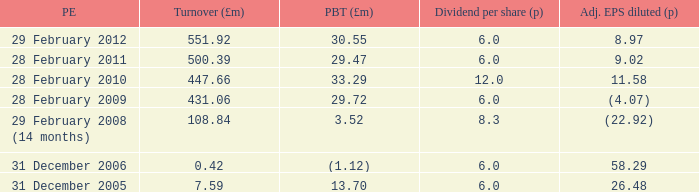How many items appear in the dividend per share when the turnover is 0.42? 1.0. 